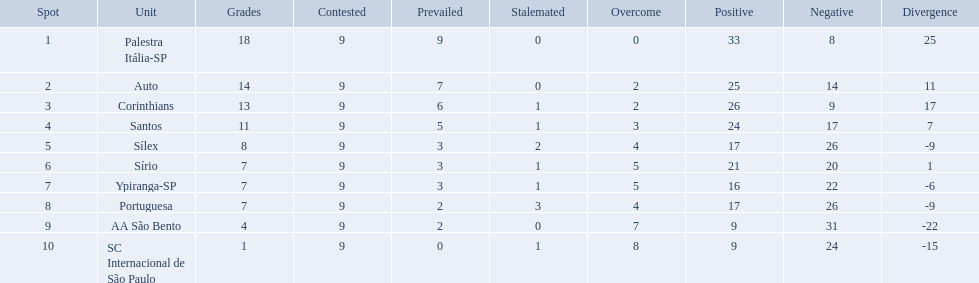What teams played in 1926? Palestra Itália-SP, Auto, Corinthians, Santos, Sílex, Sírio, Ypiranga-SP, Portuguesa, AA São Bento, SC Internacional de São Paulo. Did any team lose zero games? Palestra Itália-SP. What are all the teams? Palestra Itália-SP, Auto, Corinthians, Santos, Sílex, Sírio, Ypiranga-SP, Portuguesa, AA São Bento, SC Internacional de São Paulo. Could you help me parse every detail presented in this table? {'header': ['Spot', 'Unit', 'Grades', 'Contested', 'Prevailed', 'Stalemated', 'Overcome', 'Positive', 'Negative', 'Divergence'], 'rows': [['1', 'Palestra Itália-SP', '18', '9', '9', '0', '0', '33', '8', '25'], ['2', 'Auto', '14', '9', '7', '0', '2', '25', '14', '11'], ['3', 'Corinthians', '13', '9', '6', '1', '2', '26', '9', '17'], ['4', 'Santos', '11', '9', '5', '1', '3', '24', '17', '7'], ['5', 'Sílex', '8', '9', '3', '2', '4', '17', '26', '-9'], ['6', 'Sírio', '7', '9', '3', '1', '5', '21', '20', '1'], ['7', 'Ypiranga-SP', '7', '9', '3', '1', '5', '16', '22', '-6'], ['8', 'Portuguesa', '7', '9', '2', '3', '4', '17', '26', '-9'], ['9', 'AA São Bento', '4', '9', '2', '0', '7', '9', '31', '-22'], ['10', 'SC Internacional de São Paulo', '1', '9', '0', '1', '8', '9', '24', '-15']]} How many times did each team lose? 0, 2, 2, 3, 4, 5, 5, 4, 7, 8. And which team never lost? Palestra Itália-SP. How many games did each team play? 9, 9, 9, 9, 9, 9, 9, 9, 9, 9. Did any team score 13 points in the total games they played? 13. What is the name of that team? Corinthians. Brazilian football in 1926 what teams had no draws? Palestra Itália-SP, Auto, AA São Bento. Of the teams with no draws name the 2 who lost the lease. Palestra Itália-SP, Auto. What team of the 2 who lost the least and had no draws had the highest difference? Palestra Itália-SP. What were the top three amounts of games won for 1926 in brazilian football season? 9, 7, 6. What were the top amount of games won for 1926 in brazilian football season? 9. Would you mind parsing the complete table? {'header': ['Spot', 'Unit', 'Grades', 'Contested', 'Prevailed', 'Stalemated', 'Overcome', 'Positive', 'Negative', 'Divergence'], 'rows': [['1', 'Palestra Itália-SP', '18', '9', '9', '0', '0', '33', '8', '25'], ['2', 'Auto', '14', '9', '7', '0', '2', '25', '14', '11'], ['3', 'Corinthians', '13', '9', '6', '1', '2', '26', '9', '17'], ['4', 'Santos', '11', '9', '5', '1', '3', '24', '17', '7'], ['5', 'Sílex', '8', '9', '3', '2', '4', '17', '26', '-9'], ['6', 'Sírio', '7', '9', '3', '1', '5', '21', '20', '1'], ['7', 'Ypiranga-SP', '7', '9', '3', '1', '5', '16', '22', '-6'], ['8', 'Portuguesa', '7', '9', '2', '3', '4', '17', '26', '-9'], ['9', 'AA São Bento', '4', '9', '2', '0', '7', '9', '31', '-22'], ['10', 'SC Internacional de São Paulo', '1', '9', '0', '1', '8', '9', '24', '-15']]} What team won the top amount of games Palestra Itália-SP. 